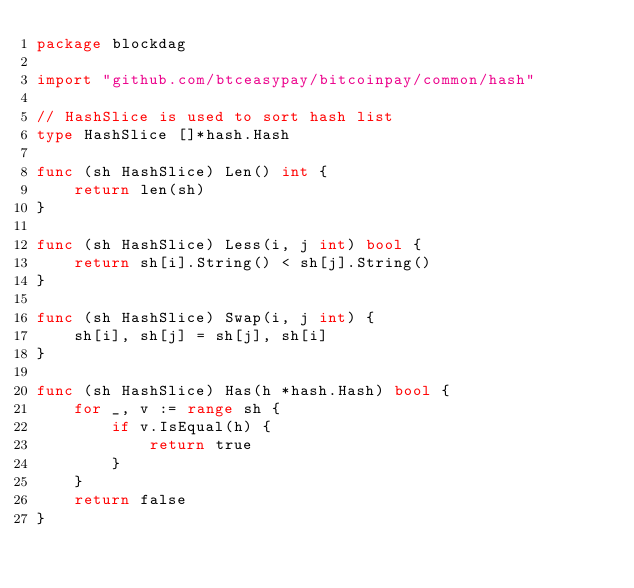<code> <loc_0><loc_0><loc_500><loc_500><_Go_>package blockdag

import "github.com/btceasypay/bitcoinpay/common/hash"

// HashSlice is used to sort hash list
type HashSlice []*hash.Hash

func (sh HashSlice) Len() int {
	return len(sh)
}

func (sh HashSlice) Less(i, j int) bool {
	return sh[i].String() < sh[j].String()
}

func (sh HashSlice) Swap(i, j int) {
	sh[i], sh[j] = sh[j], sh[i]
}

func (sh HashSlice) Has(h *hash.Hash) bool {
	for _, v := range sh {
		if v.IsEqual(h) {
			return true
		}
	}
	return false
}
</code> 